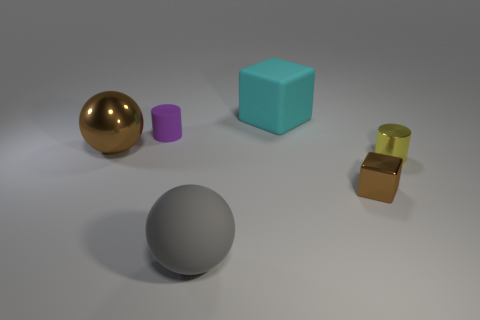Add 2 big shiny balls. How many objects exist? 8 Subtract all brown spheres. How many spheres are left? 1 Subtract 2 cylinders. How many cylinders are left? 0 Add 6 brown objects. How many brown objects are left? 8 Add 5 tiny cubes. How many tiny cubes exist? 6 Subtract 0 brown cylinders. How many objects are left? 6 Subtract all cubes. How many objects are left? 4 Subtract all gray spheres. Subtract all brown cylinders. How many spheres are left? 1 Subtract all red cylinders. How many purple blocks are left? 0 Subtract all gray matte objects. Subtract all tiny purple objects. How many objects are left? 4 